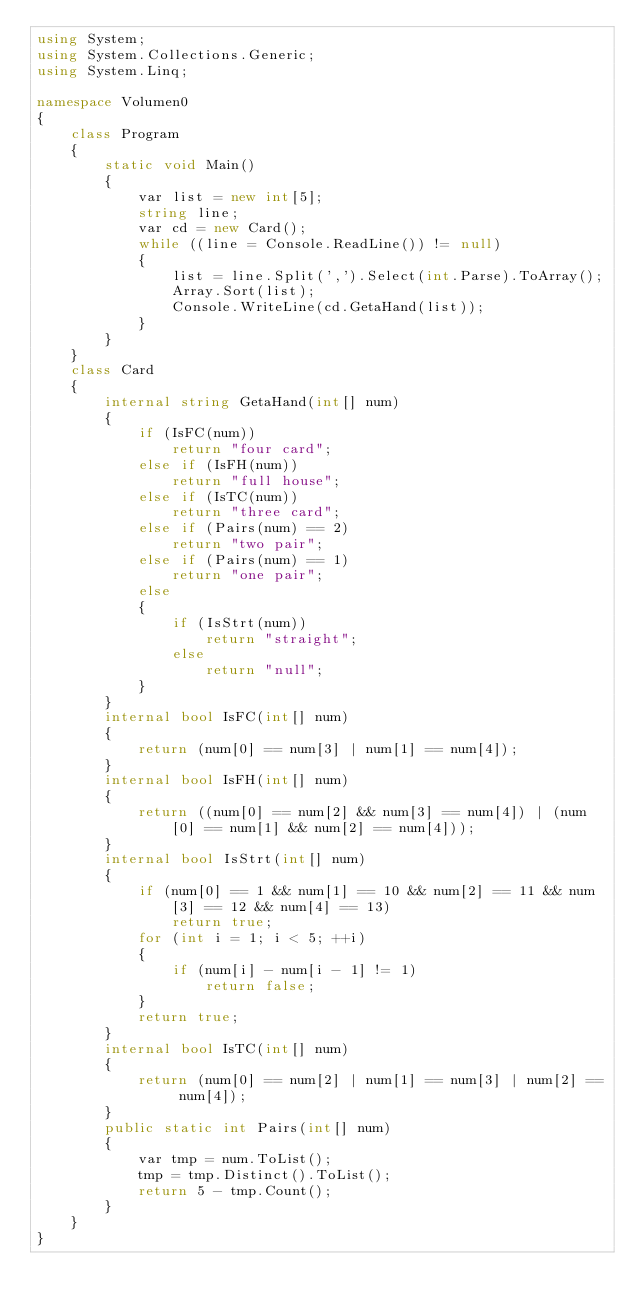<code> <loc_0><loc_0><loc_500><loc_500><_C#_>using System;
using System.Collections.Generic;
using System.Linq;

namespace Volumen0
{
    class Program
    {
        static void Main()
        {
            var list = new int[5];
            string line;
            var cd = new Card();
            while ((line = Console.ReadLine()) != null)
            {
                list = line.Split(',').Select(int.Parse).ToArray();
                Array.Sort(list);
                Console.WriteLine(cd.GetaHand(list));
            }
        }
    }
    class Card
    {
        internal string GetaHand(int[] num)
        {
            if (IsFC(num))
                return "four card";
            else if (IsFH(num))
                return "full house";
            else if (IsTC(num))
                return "three card";
            else if (Pairs(num) == 2)
                return "two pair";
            else if (Pairs(num) == 1)
                return "one pair";
            else
            {
                if (IsStrt(num))
                    return "straight";
                else
                    return "null";
            }
        }
        internal bool IsFC(int[] num)
        {
            return (num[0] == num[3] | num[1] == num[4]);
        }
        internal bool IsFH(int[] num)
        {
            return ((num[0] == num[2] && num[3] == num[4]) | (num[0] == num[1] && num[2] == num[4]));
        }
        internal bool IsStrt(int[] num)
        {
            if (num[0] == 1 && num[1] == 10 && num[2] == 11 && num[3] == 12 && num[4] == 13)
                return true;
            for (int i = 1; i < 5; ++i)
            {
                if (num[i] - num[i - 1] != 1)
                    return false;
            }
            return true;
        }
        internal bool IsTC(int[] num)
        {
            return (num[0] == num[2] | num[1] == num[3] | num[2] == num[4]);
        }
        public static int Pairs(int[] num)
        {
            var tmp = num.ToList();
            tmp = tmp.Distinct().ToList();
            return 5 - tmp.Count();
        }
    }
}
</code> 